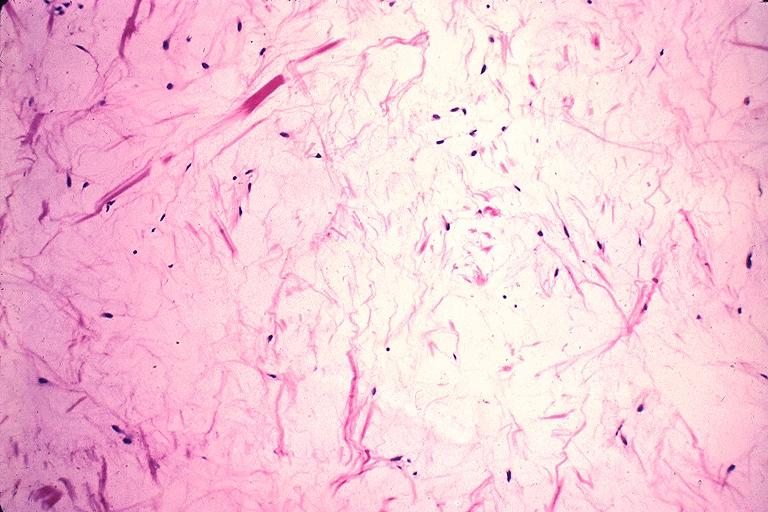does this great toe show odontogenic myxoma?
Answer the question using a single word or phrase. No 